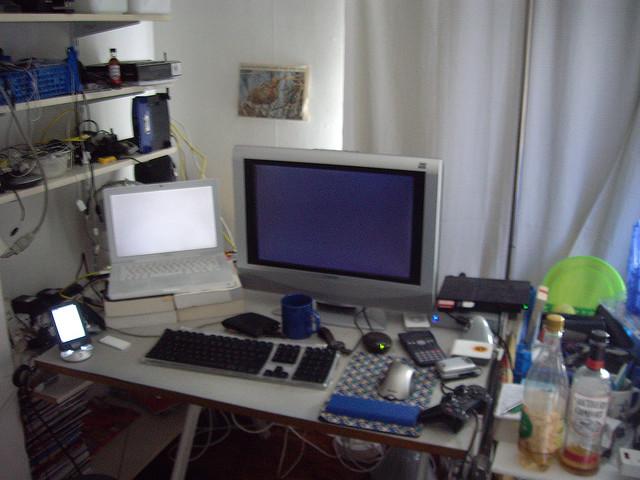What type of gaming controller is on the desk?
Be succinct. Playstation. How many computers are there?
Be succinct. 2. Is the TV on?
Concise answer only. No. Is the monitor on?
Short answer required. Yes. What is in the plastic bottle?
Give a very brief answer. Soda. Is the computer turned off?
Give a very brief answer. No. What color is the mouse pad?
Give a very brief answer. Blue. Is there a image on the screen?
Write a very short answer. No. Is the computer turned on?
Give a very brief answer. Yes. What is the green item?
Keep it brief. Frisbee. Is there anything to drink?
Concise answer only. Yes. 